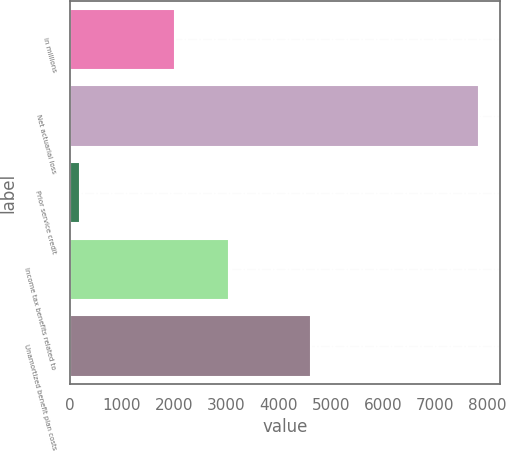Convert chart to OTSL. <chart><loc_0><loc_0><loc_500><loc_500><bar_chart><fcel>in millions<fcel>Net actuarial loss<fcel>Prior service credit<fcel>Income tax benefits related to<fcel>Unamortized benefit plan costs<nl><fcel>2017<fcel>7842<fcel>187<fcel>3042<fcel>4613<nl></chart> 